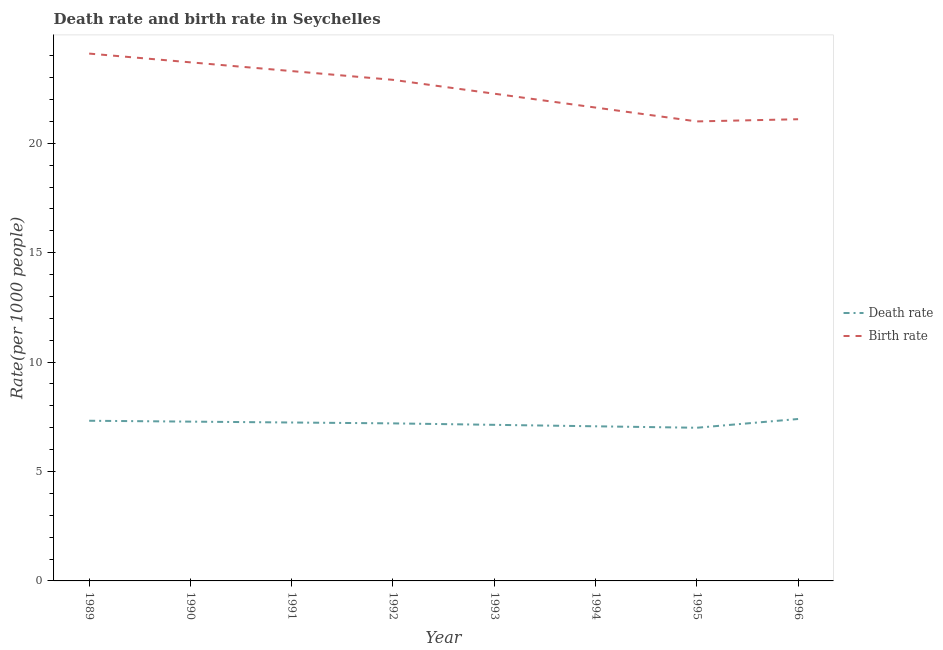How many different coloured lines are there?
Your response must be concise. 2. What is the death rate in 1994?
Your answer should be compact. 7.07. Across all years, what is the maximum death rate?
Your answer should be compact. 7.4. Across all years, what is the minimum death rate?
Your response must be concise. 7. In which year was the birth rate maximum?
Your answer should be very brief. 1989. In which year was the death rate minimum?
Give a very brief answer. 1995. What is the total birth rate in the graph?
Offer a very short reply. 180. What is the difference between the death rate in 1994 and that in 1996?
Offer a terse response. -0.33. What is the difference between the death rate in 1991 and the birth rate in 1995?
Provide a short and direct response. -13.76. What is the average death rate per year?
Ensure brevity in your answer.  7.21. In the year 1992, what is the difference between the death rate and birth rate?
Give a very brief answer. -15.7. In how many years, is the death rate greater than 23?
Keep it short and to the point. 0. What is the ratio of the death rate in 1991 to that in 1995?
Your response must be concise. 1.03. What is the difference between the highest and the second highest death rate?
Ensure brevity in your answer.  0.08. What is the difference between the highest and the lowest death rate?
Your answer should be very brief. 0.4. In how many years, is the birth rate greater than the average birth rate taken over all years?
Make the answer very short. 4. Does the birth rate monotonically increase over the years?
Offer a terse response. No. Is the birth rate strictly less than the death rate over the years?
Give a very brief answer. No. How many lines are there?
Ensure brevity in your answer.  2. Are the values on the major ticks of Y-axis written in scientific E-notation?
Provide a succinct answer. No. Does the graph contain any zero values?
Make the answer very short. No. Where does the legend appear in the graph?
Make the answer very short. Center right. What is the title of the graph?
Your response must be concise. Death rate and birth rate in Seychelles. Does "Rural" appear as one of the legend labels in the graph?
Your response must be concise. No. What is the label or title of the X-axis?
Give a very brief answer. Year. What is the label or title of the Y-axis?
Make the answer very short. Rate(per 1000 people). What is the Rate(per 1000 people) of Death rate in 1989?
Make the answer very short. 7.32. What is the Rate(per 1000 people) in Birth rate in 1989?
Keep it short and to the point. 24.1. What is the Rate(per 1000 people) of Death rate in 1990?
Provide a succinct answer. 7.28. What is the Rate(per 1000 people) of Birth rate in 1990?
Ensure brevity in your answer.  23.7. What is the Rate(per 1000 people) in Death rate in 1991?
Your answer should be compact. 7.24. What is the Rate(per 1000 people) in Birth rate in 1991?
Give a very brief answer. 23.3. What is the Rate(per 1000 people) in Death rate in 1992?
Provide a succinct answer. 7.2. What is the Rate(per 1000 people) of Birth rate in 1992?
Offer a terse response. 22.9. What is the Rate(per 1000 people) in Death rate in 1993?
Provide a short and direct response. 7.13. What is the Rate(per 1000 people) of Birth rate in 1993?
Give a very brief answer. 22.27. What is the Rate(per 1000 people) of Death rate in 1994?
Offer a terse response. 7.07. What is the Rate(per 1000 people) in Birth rate in 1994?
Keep it short and to the point. 21.63. What is the Rate(per 1000 people) in Death rate in 1996?
Keep it short and to the point. 7.4. What is the Rate(per 1000 people) of Birth rate in 1996?
Your answer should be compact. 21.1. Across all years, what is the maximum Rate(per 1000 people) of Birth rate?
Provide a succinct answer. 24.1. Across all years, what is the minimum Rate(per 1000 people) of Death rate?
Your answer should be compact. 7. Across all years, what is the minimum Rate(per 1000 people) of Birth rate?
Offer a terse response. 21. What is the total Rate(per 1000 people) of Death rate in the graph?
Make the answer very short. 57.64. What is the total Rate(per 1000 people) in Birth rate in the graph?
Provide a short and direct response. 180. What is the difference between the Rate(per 1000 people) of Birth rate in 1989 and that in 1990?
Offer a very short reply. 0.4. What is the difference between the Rate(per 1000 people) of Death rate in 1989 and that in 1991?
Keep it short and to the point. 0.08. What is the difference between the Rate(per 1000 people) in Death rate in 1989 and that in 1992?
Your response must be concise. 0.12. What is the difference between the Rate(per 1000 people) in Death rate in 1989 and that in 1993?
Make the answer very short. 0.19. What is the difference between the Rate(per 1000 people) of Birth rate in 1989 and that in 1993?
Your response must be concise. 1.83. What is the difference between the Rate(per 1000 people) in Death rate in 1989 and that in 1994?
Give a very brief answer. 0.25. What is the difference between the Rate(per 1000 people) of Birth rate in 1989 and that in 1994?
Provide a short and direct response. 2.47. What is the difference between the Rate(per 1000 people) of Death rate in 1989 and that in 1995?
Offer a terse response. 0.32. What is the difference between the Rate(per 1000 people) of Death rate in 1989 and that in 1996?
Offer a very short reply. -0.08. What is the difference between the Rate(per 1000 people) in Birth rate in 1989 and that in 1996?
Provide a short and direct response. 3. What is the difference between the Rate(per 1000 people) in Death rate in 1990 and that in 1992?
Offer a very short reply. 0.08. What is the difference between the Rate(per 1000 people) in Birth rate in 1990 and that in 1992?
Provide a short and direct response. 0.8. What is the difference between the Rate(per 1000 people) of Death rate in 1990 and that in 1993?
Offer a terse response. 0.15. What is the difference between the Rate(per 1000 people) of Birth rate in 1990 and that in 1993?
Make the answer very short. 1.43. What is the difference between the Rate(per 1000 people) in Death rate in 1990 and that in 1994?
Give a very brief answer. 0.21. What is the difference between the Rate(per 1000 people) of Birth rate in 1990 and that in 1994?
Provide a succinct answer. 2.07. What is the difference between the Rate(per 1000 people) of Death rate in 1990 and that in 1995?
Ensure brevity in your answer.  0.28. What is the difference between the Rate(per 1000 people) of Death rate in 1990 and that in 1996?
Your answer should be compact. -0.12. What is the difference between the Rate(per 1000 people) in Birth rate in 1990 and that in 1996?
Your answer should be compact. 2.6. What is the difference between the Rate(per 1000 people) of Death rate in 1991 and that in 1992?
Your answer should be very brief. 0.04. What is the difference between the Rate(per 1000 people) of Death rate in 1991 and that in 1993?
Provide a short and direct response. 0.11. What is the difference between the Rate(per 1000 people) in Death rate in 1991 and that in 1994?
Keep it short and to the point. 0.17. What is the difference between the Rate(per 1000 people) of Death rate in 1991 and that in 1995?
Offer a terse response. 0.24. What is the difference between the Rate(per 1000 people) in Death rate in 1991 and that in 1996?
Your answer should be compact. -0.16. What is the difference between the Rate(per 1000 people) in Death rate in 1992 and that in 1993?
Your response must be concise. 0.07. What is the difference between the Rate(per 1000 people) in Birth rate in 1992 and that in 1993?
Provide a succinct answer. 0.63. What is the difference between the Rate(per 1000 people) of Death rate in 1992 and that in 1994?
Provide a short and direct response. 0.13. What is the difference between the Rate(per 1000 people) of Birth rate in 1992 and that in 1994?
Keep it short and to the point. 1.27. What is the difference between the Rate(per 1000 people) of Death rate in 1992 and that in 1995?
Your answer should be very brief. 0.2. What is the difference between the Rate(per 1000 people) of Death rate in 1992 and that in 1996?
Ensure brevity in your answer.  -0.2. What is the difference between the Rate(per 1000 people) in Death rate in 1993 and that in 1994?
Provide a short and direct response. 0.07. What is the difference between the Rate(per 1000 people) in Birth rate in 1993 and that in 1994?
Keep it short and to the point. 0.63. What is the difference between the Rate(per 1000 people) in Death rate in 1993 and that in 1995?
Ensure brevity in your answer.  0.13. What is the difference between the Rate(per 1000 people) of Birth rate in 1993 and that in 1995?
Provide a succinct answer. 1.27. What is the difference between the Rate(per 1000 people) in Death rate in 1993 and that in 1996?
Give a very brief answer. -0.27. What is the difference between the Rate(per 1000 people) of Death rate in 1994 and that in 1995?
Keep it short and to the point. 0.07. What is the difference between the Rate(per 1000 people) in Birth rate in 1994 and that in 1995?
Offer a very short reply. 0.63. What is the difference between the Rate(per 1000 people) of Death rate in 1994 and that in 1996?
Give a very brief answer. -0.33. What is the difference between the Rate(per 1000 people) in Birth rate in 1994 and that in 1996?
Provide a short and direct response. 0.53. What is the difference between the Rate(per 1000 people) in Death rate in 1989 and the Rate(per 1000 people) in Birth rate in 1990?
Keep it short and to the point. -16.38. What is the difference between the Rate(per 1000 people) in Death rate in 1989 and the Rate(per 1000 people) in Birth rate in 1991?
Your response must be concise. -15.98. What is the difference between the Rate(per 1000 people) of Death rate in 1989 and the Rate(per 1000 people) of Birth rate in 1992?
Offer a terse response. -15.58. What is the difference between the Rate(per 1000 people) in Death rate in 1989 and the Rate(per 1000 people) in Birth rate in 1993?
Make the answer very short. -14.95. What is the difference between the Rate(per 1000 people) of Death rate in 1989 and the Rate(per 1000 people) of Birth rate in 1994?
Your response must be concise. -14.31. What is the difference between the Rate(per 1000 people) in Death rate in 1989 and the Rate(per 1000 people) in Birth rate in 1995?
Make the answer very short. -13.68. What is the difference between the Rate(per 1000 people) in Death rate in 1989 and the Rate(per 1000 people) in Birth rate in 1996?
Your answer should be very brief. -13.78. What is the difference between the Rate(per 1000 people) of Death rate in 1990 and the Rate(per 1000 people) of Birth rate in 1991?
Make the answer very short. -16.02. What is the difference between the Rate(per 1000 people) of Death rate in 1990 and the Rate(per 1000 people) of Birth rate in 1992?
Your answer should be very brief. -15.62. What is the difference between the Rate(per 1000 people) in Death rate in 1990 and the Rate(per 1000 people) in Birth rate in 1993?
Your answer should be compact. -14.99. What is the difference between the Rate(per 1000 people) in Death rate in 1990 and the Rate(per 1000 people) in Birth rate in 1994?
Your response must be concise. -14.35. What is the difference between the Rate(per 1000 people) of Death rate in 1990 and the Rate(per 1000 people) of Birth rate in 1995?
Your answer should be compact. -13.72. What is the difference between the Rate(per 1000 people) in Death rate in 1990 and the Rate(per 1000 people) in Birth rate in 1996?
Keep it short and to the point. -13.82. What is the difference between the Rate(per 1000 people) of Death rate in 1991 and the Rate(per 1000 people) of Birth rate in 1992?
Make the answer very short. -15.66. What is the difference between the Rate(per 1000 people) of Death rate in 1991 and the Rate(per 1000 people) of Birth rate in 1993?
Provide a short and direct response. -15.03. What is the difference between the Rate(per 1000 people) of Death rate in 1991 and the Rate(per 1000 people) of Birth rate in 1994?
Give a very brief answer. -14.39. What is the difference between the Rate(per 1000 people) of Death rate in 1991 and the Rate(per 1000 people) of Birth rate in 1995?
Provide a short and direct response. -13.76. What is the difference between the Rate(per 1000 people) in Death rate in 1991 and the Rate(per 1000 people) in Birth rate in 1996?
Keep it short and to the point. -13.86. What is the difference between the Rate(per 1000 people) of Death rate in 1992 and the Rate(per 1000 people) of Birth rate in 1993?
Provide a succinct answer. -15.07. What is the difference between the Rate(per 1000 people) of Death rate in 1992 and the Rate(per 1000 people) of Birth rate in 1994?
Give a very brief answer. -14.43. What is the difference between the Rate(per 1000 people) of Death rate in 1992 and the Rate(per 1000 people) of Birth rate in 1995?
Your answer should be very brief. -13.8. What is the difference between the Rate(per 1000 people) of Death rate in 1992 and the Rate(per 1000 people) of Birth rate in 1996?
Give a very brief answer. -13.9. What is the difference between the Rate(per 1000 people) of Death rate in 1993 and the Rate(per 1000 people) of Birth rate in 1994?
Your answer should be compact. -14.5. What is the difference between the Rate(per 1000 people) in Death rate in 1993 and the Rate(per 1000 people) in Birth rate in 1995?
Offer a very short reply. -13.87. What is the difference between the Rate(per 1000 people) of Death rate in 1993 and the Rate(per 1000 people) of Birth rate in 1996?
Your answer should be very brief. -13.97. What is the difference between the Rate(per 1000 people) in Death rate in 1994 and the Rate(per 1000 people) in Birth rate in 1995?
Make the answer very short. -13.93. What is the difference between the Rate(per 1000 people) of Death rate in 1994 and the Rate(per 1000 people) of Birth rate in 1996?
Your answer should be very brief. -14.03. What is the difference between the Rate(per 1000 people) in Death rate in 1995 and the Rate(per 1000 people) in Birth rate in 1996?
Give a very brief answer. -14.1. What is the average Rate(per 1000 people) of Death rate per year?
Provide a short and direct response. 7.21. In the year 1989, what is the difference between the Rate(per 1000 people) in Death rate and Rate(per 1000 people) in Birth rate?
Make the answer very short. -16.78. In the year 1990, what is the difference between the Rate(per 1000 people) of Death rate and Rate(per 1000 people) of Birth rate?
Keep it short and to the point. -16.42. In the year 1991, what is the difference between the Rate(per 1000 people) in Death rate and Rate(per 1000 people) in Birth rate?
Keep it short and to the point. -16.06. In the year 1992, what is the difference between the Rate(per 1000 people) of Death rate and Rate(per 1000 people) of Birth rate?
Offer a very short reply. -15.7. In the year 1993, what is the difference between the Rate(per 1000 people) of Death rate and Rate(per 1000 people) of Birth rate?
Offer a very short reply. -15.13. In the year 1994, what is the difference between the Rate(per 1000 people) of Death rate and Rate(per 1000 people) of Birth rate?
Make the answer very short. -14.57. In the year 1996, what is the difference between the Rate(per 1000 people) in Death rate and Rate(per 1000 people) in Birth rate?
Provide a short and direct response. -13.7. What is the ratio of the Rate(per 1000 people) of Birth rate in 1989 to that in 1990?
Your answer should be very brief. 1.02. What is the ratio of the Rate(per 1000 people) of Birth rate in 1989 to that in 1991?
Your response must be concise. 1.03. What is the ratio of the Rate(per 1000 people) in Death rate in 1989 to that in 1992?
Keep it short and to the point. 1.02. What is the ratio of the Rate(per 1000 people) of Birth rate in 1989 to that in 1992?
Give a very brief answer. 1.05. What is the ratio of the Rate(per 1000 people) of Death rate in 1989 to that in 1993?
Your answer should be very brief. 1.03. What is the ratio of the Rate(per 1000 people) in Birth rate in 1989 to that in 1993?
Your answer should be very brief. 1.08. What is the ratio of the Rate(per 1000 people) of Death rate in 1989 to that in 1994?
Provide a succinct answer. 1.04. What is the ratio of the Rate(per 1000 people) in Birth rate in 1989 to that in 1994?
Your answer should be compact. 1.11. What is the ratio of the Rate(per 1000 people) of Death rate in 1989 to that in 1995?
Provide a succinct answer. 1.05. What is the ratio of the Rate(per 1000 people) of Birth rate in 1989 to that in 1995?
Your response must be concise. 1.15. What is the ratio of the Rate(per 1000 people) in Birth rate in 1989 to that in 1996?
Offer a very short reply. 1.14. What is the ratio of the Rate(per 1000 people) of Death rate in 1990 to that in 1991?
Your answer should be very brief. 1.01. What is the ratio of the Rate(per 1000 people) in Birth rate in 1990 to that in 1991?
Offer a very short reply. 1.02. What is the ratio of the Rate(per 1000 people) in Death rate in 1990 to that in 1992?
Provide a short and direct response. 1.01. What is the ratio of the Rate(per 1000 people) of Birth rate in 1990 to that in 1992?
Provide a short and direct response. 1.03. What is the ratio of the Rate(per 1000 people) in Death rate in 1990 to that in 1993?
Ensure brevity in your answer.  1.02. What is the ratio of the Rate(per 1000 people) in Birth rate in 1990 to that in 1993?
Your answer should be compact. 1.06. What is the ratio of the Rate(per 1000 people) of Death rate in 1990 to that in 1994?
Keep it short and to the point. 1.03. What is the ratio of the Rate(per 1000 people) in Birth rate in 1990 to that in 1994?
Your response must be concise. 1.1. What is the ratio of the Rate(per 1000 people) in Death rate in 1990 to that in 1995?
Provide a succinct answer. 1.04. What is the ratio of the Rate(per 1000 people) of Birth rate in 1990 to that in 1995?
Your answer should be compact. 1.13. What is the ratio of the Rate(per 1000 people) of Death rate in 1990 to that in 1996?
Your answer should be very brief. 0.98. What is the ratio of the Rate(per 1000 people) of Birth rate in 1990 to that in 1996?
Your answer should be very brief. 1.12. What is the ratio of the Rate(per 1000 people) of Death rate in 1991 to that in 1992?
Offer a terse response. 1.01. What is the ratio of the Rate(per 1000 people) in Birth rate in 1991 to that in 1992?
Your answer should be compact. 1.02. What is the ratio of the Rate(per 1000 people) of Birth rate in 1991 to that in 1993?
Your answer should be very brief. 1.05. What is the ratio of the Rate(per 1000 people) of Death rate in 1991 to that in 1994?
Keep it short and to the point. 1.02. What is the ratio of the Rate(per 1000 people) of Birth rate in 1991 to that in 1994?
Your answer should be very brief. 1.08. What is the ratio of the Rate(per 1000 people) of Death rate in 1991 to that in 1995?
Your answer should be compact. 1.03. What is the ratio of the Rate(per 1000 people) of Birth rate in 1991 to that in 1995?
Provide a succinct answer. 1.11. What is the ratio of the Rate(per 1000 people) in Death rate in 1991 to that in 1996?
Ensure brevity in your answer.  0.98. What is the ratio of the Rate(per 1000 people) in Birth rate in 1991 to that in 1996?
Your answer should be very brief. 1.1. What is the ratio of the Rate(per 1000 people) of Death rate in 1992 to that in 1993?
Your answer should be compact. 1.01. What is the ratio of the Rate(per 1000 people) of Birth rate in 1992 to that in 1993?
Keep it short and to the point. 1.03. What is the ratio of the Rate(per 1000 people) of Death rate in 1992 to that in 1994?
Your response must be concise. 1.02. What is the ratio of the Rate(per 1000 people) of Birth rate in 1992 to that in 1994?
Keep it short and to the point. 1.06. What is the ratio of the Rate(per 1000 people) in Death rate in 1992 to that in 1995?
Make the answer very short. 1.03. What is the ratio of the Rate(per 1000 people) in Birth rate in 1992 to that in 1995?
Offer a terse response. 1.09. What is the ratio of the Rate(per 1000 people) in Birth rate in 1992 to that in 1996?
Keep it short and to the point. 1.09. What is the ratio of the Rate(per 1000 people) of Death rate in 1993 to that in 1994?
Keep it short and to the point. 1.01. What is the ratio of the Rate(per 1000 people) of Birth rate in 1993 to that in 1994?
Your response must be concise. 1.03. What is the ratio of the Rate(per 1000 people) of Birth rate in 1993 to that in 1995?
Offer a terse response. 1.06. What is the ratio of the Rate(per 1000 people) in Death rate in 1993 to that in 1996?
Give a very brief answer. 0.96. What is the ratio of the Rate(per 1000 people) in Birth rate in 1993 to that in 1996?
Ensure brevity in your answer.  1.06. What is the ratio of the Rate(per 1000 people) in Death rate in 1994 to that in 1995?
Ensure brevity in your answer.  1.01. What is the ratio of the Rate(per 1000 people) of Birth rate in 1994 to that in 1995?
Your answer should be very brief. 1.03. What is the ratio of the Rate(per 1000 people) of Death rate in 1994 to that in 1996?
Provide a succinct answer. 0.95. What is the ratio of the Rate(per 1000 people) in Birth rate in 1994 to that in 1996?
Ensure brevity in your answer.  1.03. What is the ratio of the Rate(per 1000 people) of Death rate in 1995 to that in 1996?
Keep it short and to the point. 0.95. What is the ratio of the Rate(per 1000 people) in Birth rate in 1995 to that in 1996?
Give a very brief answer. 1. What is the difference between the highest and the second highest Rate(per 1000 people) in Birth rate?
Keep it short and to the point. 0.4. What is the difference between the highest and the lowest Rate(per 1000 people) of Birth rate?
Your answer should be compact. 3.1. 